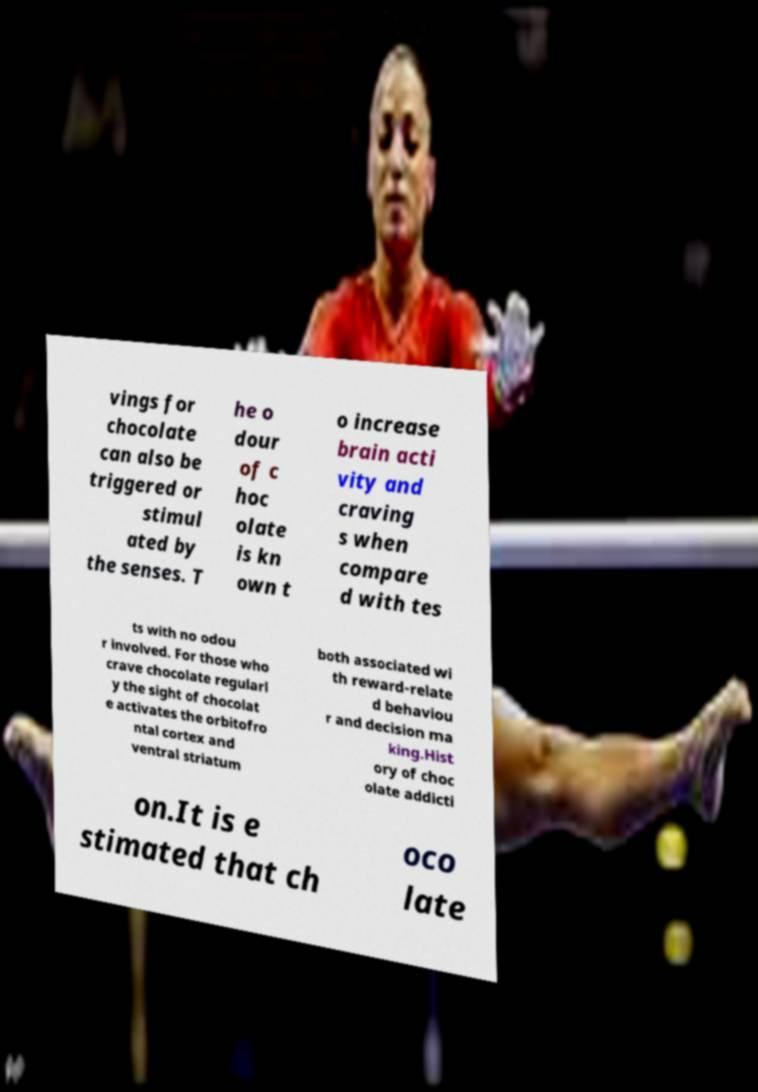There's text embedded in this image that I need extracted. Can you transcribe it verbatim? vings for chocolate can also be triggered or stimul ated by the senses. T he o dour of c hoc olate is kn own t o increase brain acti vity and craving s when compare d with tes ts with no odou r involved. For those who crave chocolate regularl y the sight of chocolat e activates the orbitofro ntal cortex and ventral striatum both associated wi th reward-relate d behaviou r and decision ma king.Hist ory of choc olate addicti on.It is e stimated that ch oco late 